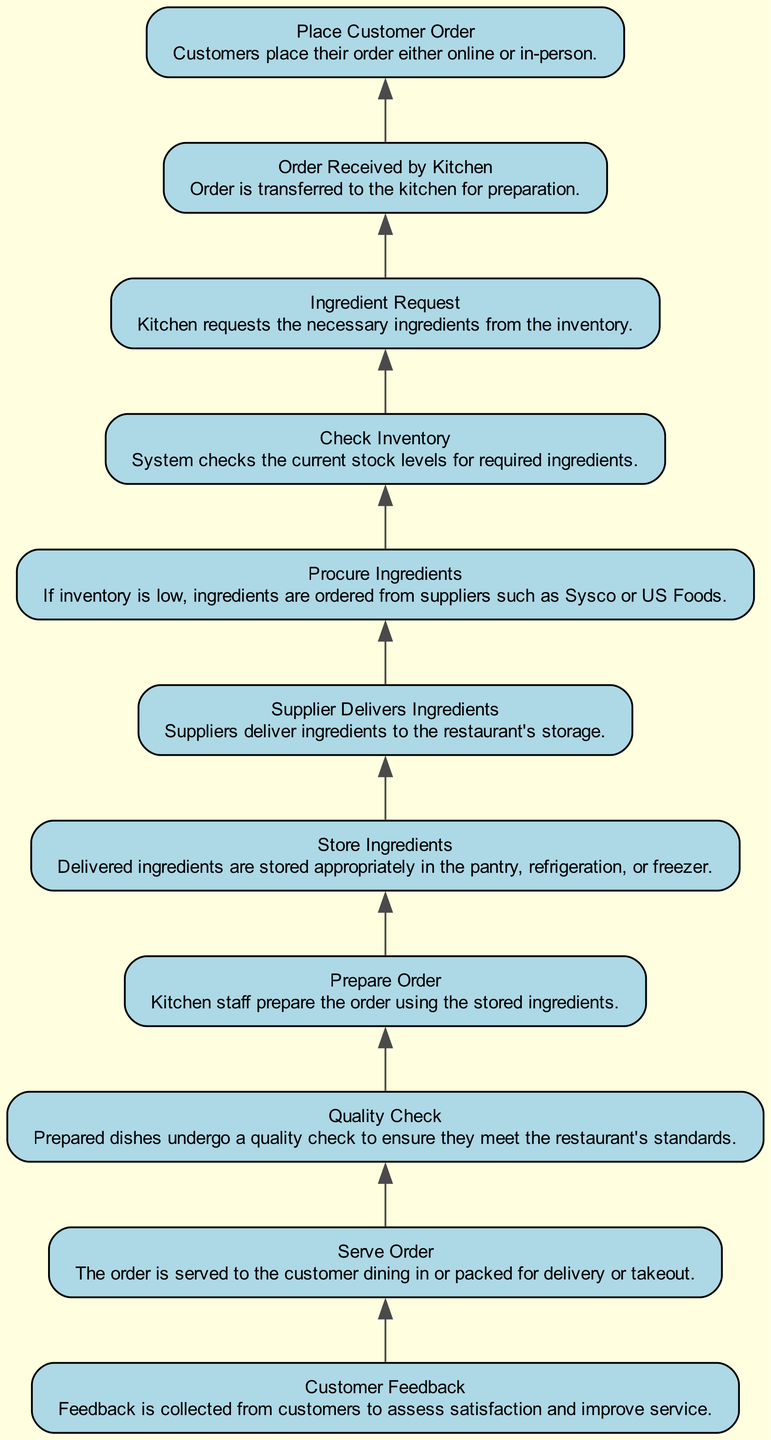What is the first step in the supply chain management process? The first step is "Place Customer Order," where customers place their order either online or in-person. This is indicated as the starting point at the bottom of the flowchart.
Answer: Place Customer Order What follows after "Quality Check"? The step that follows "Quality Check" is "Serve Order." In the flow of the diagram, after the dishes have undergone quality checks, they are served to customers or packed for delivery.
Answer: Serve Order How many total steps are in the diagram? The total number of steps in the diagram is eleven, as there are 11 distinct nodes listed from "Place Customer Order" to "Customer Feedback." Each step is a part of the process shown in the flowchart.
Answer: 11 What is the fifth step in the supply chain management process? The fifth step is "Procure Ingredients," where ingredients are ordered from suppliers if inventory is low. This is found by counting the steps from the bottom of the diagram.
Answer: Procure Ingredients What triggers the "Supplier Delivers Ingredients" step? The "Supplier Delivers Ingredients" step is triggered by the need to procure ingredients, which occurs if the inventory check shows low stock levels for the requested ingredients from the kitchen. This process reflects a direct need for supplies to continue kitchen operations.
Answer: Ingredient Request Which step is directly before "Prepare Order"? The step directly before "Prepare Order" is "Store Ingredients." After ingredients are delivered by suppliers, they must be stored properly before being used for order preparation. This shows the chronological order of activities.
Answer: Store Ingredients What is the purpose of "Customer Feedback"? The purpose of "Customer Feedback" is to assess satisfaction and improve service. It is an essential aspect of the process as it helps gather insights on the dining experience for continuous improvement.
Answer: Assess satisfaction Which step involves checking stock levels? The step that involves checking stock levels is "Check Inventory." This step is critical before any procurement actions to ensure what ingredients are available for the kitchen.
Answer: Check Inventory What are the two main actions represented by the step "Serve Order"? The two main actions represented by "Serve Order" are serving the order to customers dining in or packing it for delivery or takeout. This step encompasses both in-house dining and off-premises service options.
Answer: Serve to customer or pack for delivery 